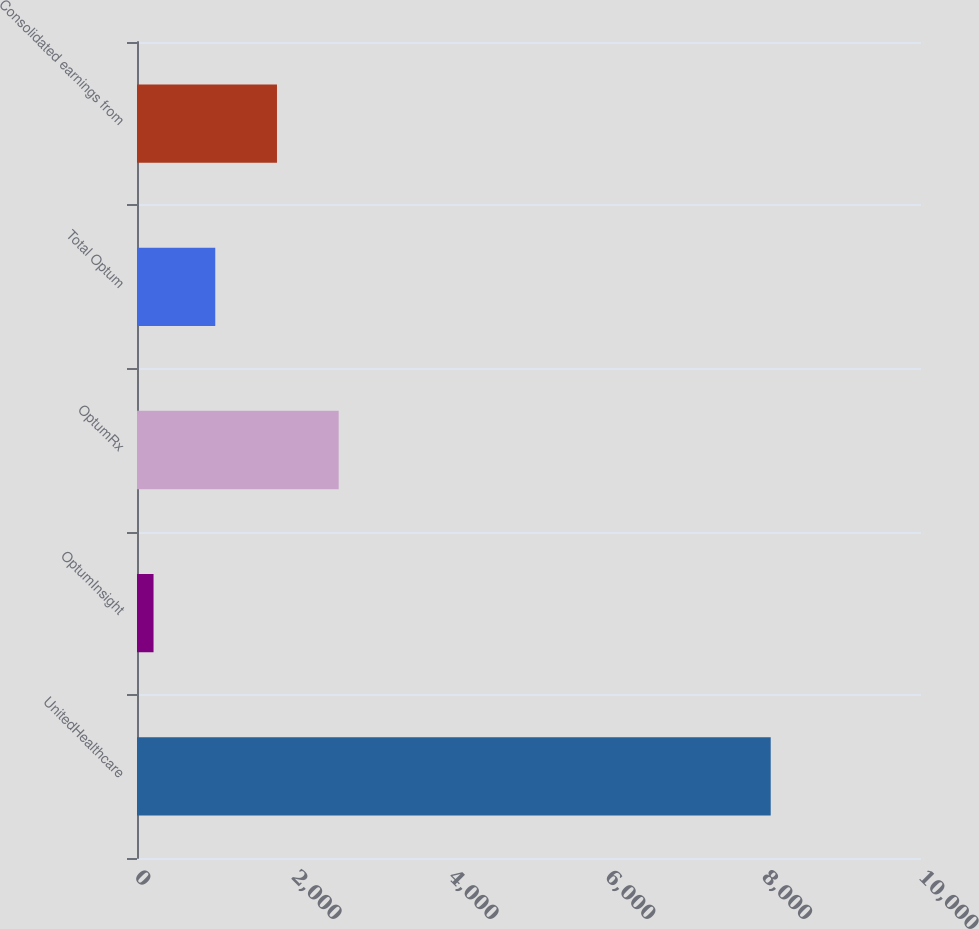Convert chart to OTSL. <chart><loc_0><loc_0><loc_500><loc_500><bar_chart><fcel>UnitedHealthcare<fcel>OptumInsight<fcel>OptumRx<fcel>Total Optum<fcel>Consolidated earnings from<nl><fcel>8083<fcel>211<fcel>2572.6<fcel>998.2<fcel>1785.4<nl></chart> 